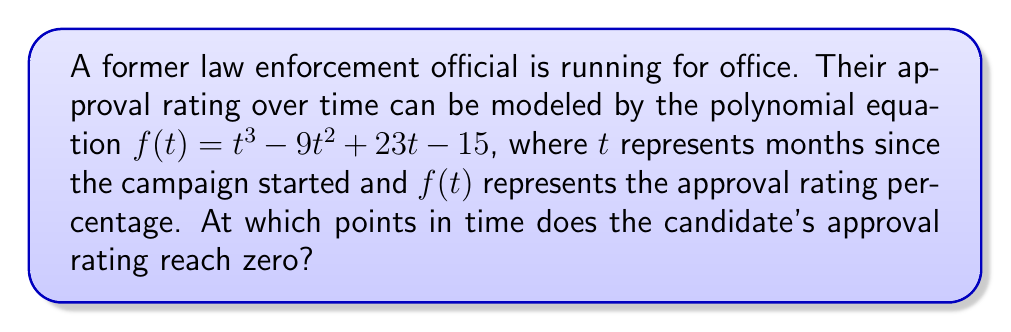What is the answer to this math problem? To find when the approval rating reaches zero, we need to solve the equation $f(t) = 0$:

1) Set up the equation:
   $t^3 - 9t^2 + 23t - 15 = 0$

2) This is a cubic equation. We can solve it by factoring:
   $(t - 1)(t^2 - 8t + 15) = 0$

3) Further factoring the quadratic term:
   $(t - 1)(t - 3)(t - 5) = 0$

4) By the zero product property, if the product of factors is zero, at least one factor must be zero. So, we set each factor to zero and solve:

   $t - 1 = 0$, $t = 1$
   $t - 3 = 0$, $t = 3$
   $t - 5 = 0$, $t = 5$

5) These values of $t$ represent the months at which the approval rating reaches zero.
Answer: 1, 3, and 5 months 